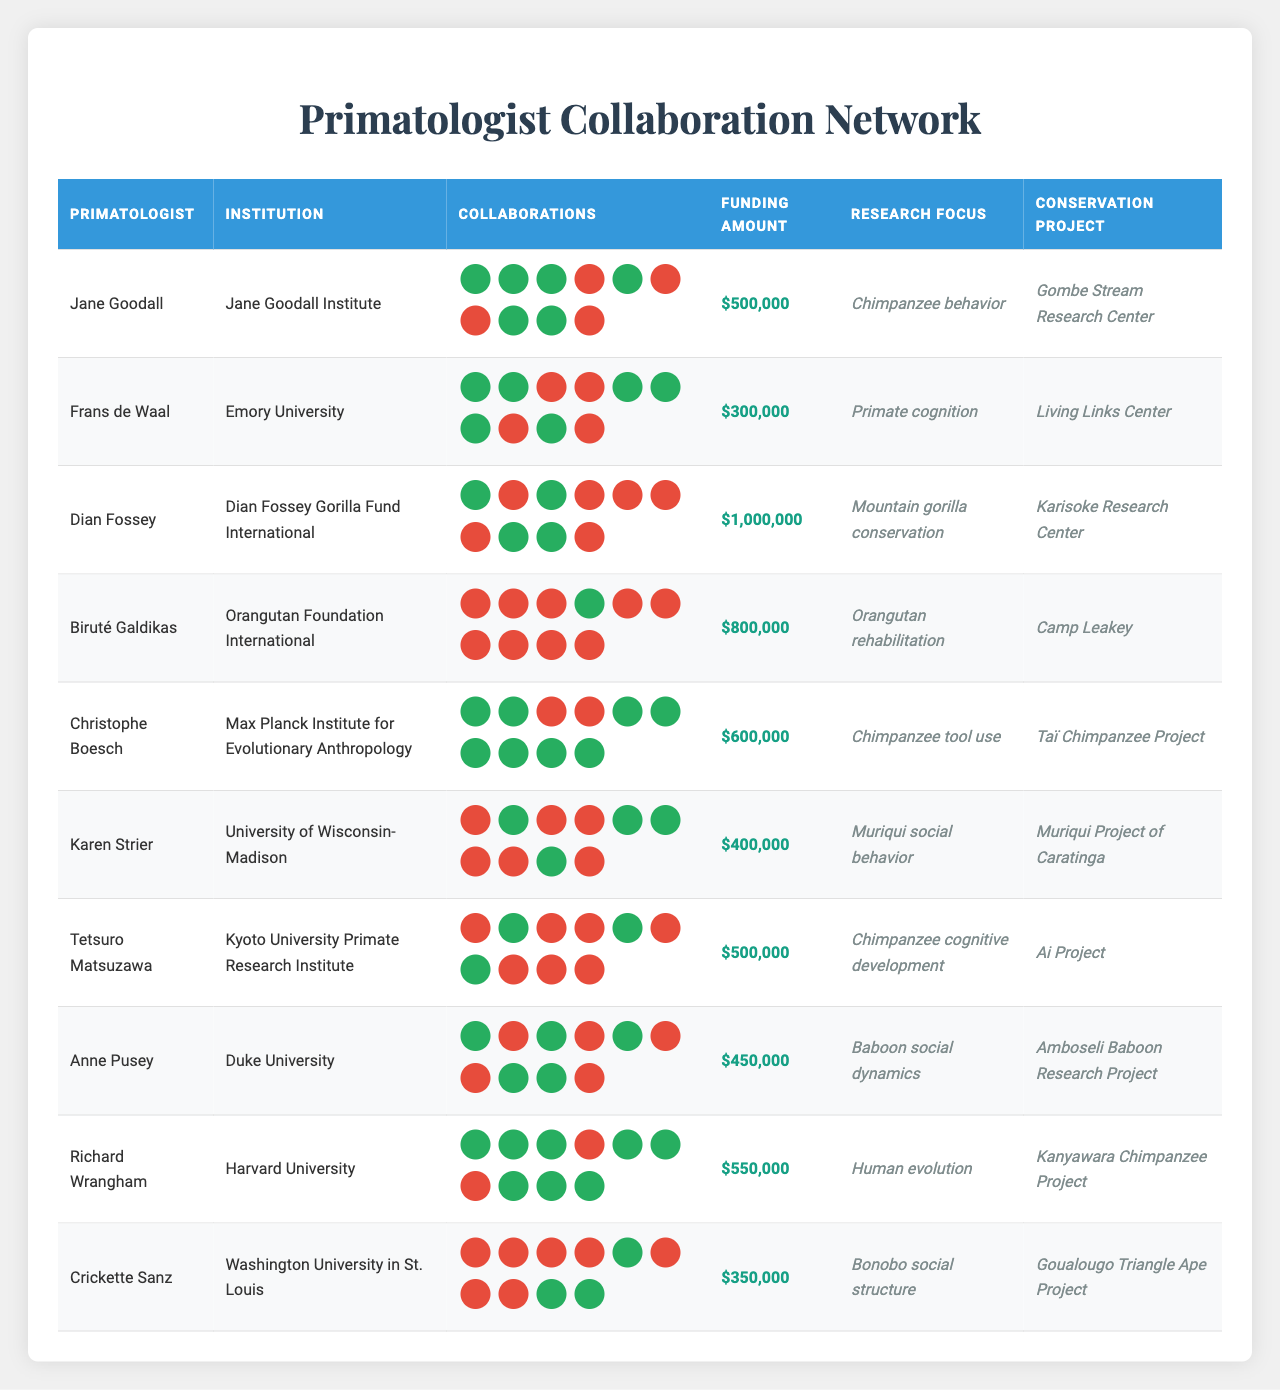What institution is associated with Jane Goodall? The table lists Jane Goodall with the Jane Goodall Institute as her affiliated institution in the respective column.
Answer: Jane Goodall Institute Which primatologist has the highest funding amount? By inspecting the funding amounts for each primatologist, Dian Fossey has the highest funding amount of $1,000,000 listed in the relevant column.
Answer: Dian Fossey How many collaborations does Tetsuro Matsuzawa have? Tetsuro Matsuzawa's row shows three active collaborations in the collaboration cells, indicating he has three collaborations.
Answer: 3 Is there a collaboration between Karen Strier and Harvard University? Looking at the collaboration row for Karen Strier, there is a 0 next to Harvard University, indicating that there is no collaboration.
Answer: No What is the funding amount for Anne Pusey? The funding amount for Anne Pusey in the funding amounts column shows $300,000.
Answer: $300,000 What institution has the highest number of collaborations in total? By counting the collaborations across all primatologists for each institution, the Max Planck Institute for Evolutionary Anthropology has a total of 6 active collaborations.
Answer: Max Planck Institute for Evolutionary Anthropology Which primatologist is involved with the Muriqui social behavior research focus? The research focus column shows Karen Strier associated with Muriqui social behavior.
Answer: Karen Strier What is the average funding amount for the institutions? Adding all the funding amounts in the table and dividing by the number of values (10) gives a total of $3,850,000, leading to an average of $385,000.
Answer: $385,000 Which two primatologists have collaborated with Duke University? By inspecting Duke University's collaboration column, Jane Goodall and Christophe Boesch are indicated as having active collaborations with a 1.
Answer: Jane Goodall, Christophe Boesch What does the collaboration status tell about the relationship between Biruté Galdikas and the institutions? Biruté Galdikas has no collaborations with most institutions except for the Orangutan Foundation International, shown by the 1 in that cell, indicating limited collaboration.
Answer: Limited collaboration How much total funding have the primatologists received for their projects? By summing the total funding amounts from the funding amounts section, the total funding received is $3,850,000.
Answer: $3,850,000 